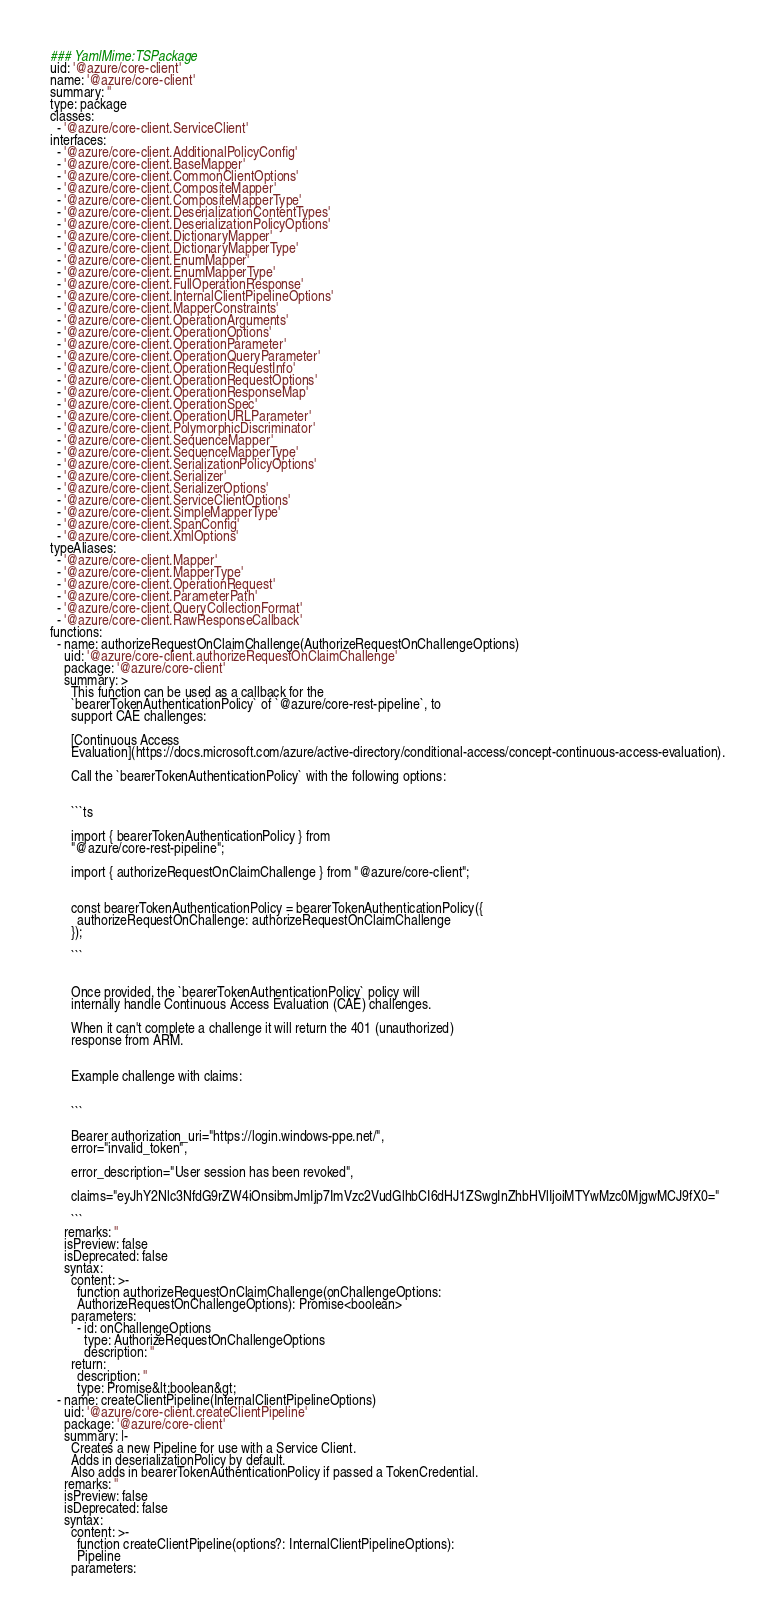Convert code to text. <code><loc_0><loc_0><loc_500><loc_500><_YAML_>### YamlMime:TSPackage
uid: '@azure/core-client'
name: '@azure/core-client'
summary: ''
type: package
classes:
  - '@azure/core-client.ServiceClient'
interfaces:
  - '@azure/core-client.AdditionalPolicyConfig'
  - '@azure/core-client.BaseMapper'
  - '@azure/core-client.CommonClientOptions'
  - '@azure/core-client.CompositeMapper'
  - '@azure/core-client.CompositeMapperType'
  - '@azure/core-client.DeserializationContentTypes'
  - '@azure/core-client.DeserializationPolicyOptions'
  - '@azure/core-client.DictionaryMapper'
  - '@azure/core-client.DictionaryMapperType'
  - '@azure/core-client.EnumMapper'
  - '@azure/core-client.EnumMapperType'
  - '@azure/core-client.FullOperationResponse'
  - '@azure/core-client.InternalClientPipelineOptions'
  - '@azure/core-client.MapperConstraints'
  - '@azure/core-client.OperationArguments'
  - '@azure/core-client.OperationOptions'
  - '@azure/core-client.OperationParameter'
  - '@azure/core-client.OperationQueryParameter'
  - '@azure/core-client.OperationRequestInfo'
  - '@azure/core-client.OperationRequestOptions'
  - '@azure/core-client.OperationResponseMap'
  - '@azure/core-client.OperationSpec'
  - '@azure/core-client.OperationURLParameter'
  - '@azure/core-client.PolymorphicDiscriminator'
  - '@azure/core-client.SequenceMapper'
  - '@azure/core-client.SequenceMapperType'
  - '@azure/core-client.SerializationPolicyOptions'
  - '@azure/core-client.Serializer'
  - '@azure/core-client.SerializerOptions'
  - '@azure/core-client.ServiceClientOptions'
  - '@azure/core-client.SimpleMapperType'
  - '@azure/core-client.SpanConfig'
  - '@azure/core-client.XmlOptions'
typeAliases:
  - '@azure/core-client.Mapper'
  - '@azure/core-client.MapperType'
  - '@azure/core-client.OperationRequest'
  - '@azure/core-client.ParameterPath'
  - '@azure/core-client.QueryCollectionFormat'
  - '@azure/core-client.RawResponseCallback'
functions:
  - name: authorizeRequestOnClaimChallenge(AuthorizeRequestOnChallengeOptions)
    uid: '@azure/core-client.authorizeRequestOnClaimChallenge'
    package: '@azure/core-client'
    summary: >
      This function can be used as a callback for the
      `bearerTokenAuthenticationPolicy` of `@azure/core-rest-pipeline`, to
      support CAE challenges:

      [Continuous Access
      Evaluation](https://docs.microsoft.com/azure/active-directory/conditional-access/concept-continuous-access-evaluation).

      Call the `bearerTokenAuthenticationPolicy` with the following options:


      ```ts

      import { bearerTokenAuthenticationPolicy } from
      "@azure/core-rest-pipeline";

      import { authorizeRequestOnClaimChallenge } from "@azure/core-client";


      const bearerTokenAuthenticationPolicy = bearerTokenAuthenticationPolicy({
        authorizeRequestOnChallenge: authorizeRequestOnClaimChallenge
      });

      ```


      Once provided, the `bearerTokenAuthenticationPolicy` policy will
      internally handle Continuous Access Evaluation (CAE) challenges.

      When it can't complete a challenge it will return the 401 (unauthorized)
      response from ARM.


      Example challenge with claims:


      ```

      Bearer authorization_uri="https://login.windows-ppe.net/",
      error="invalid_token",

      error_description="User session has been revoked",

      claims="eyJhY2Nlc3NfdG9rZW4iOnsibmJmIjp7ImVzc2VudGlhbCI6dHJ1ZSwgInZhbHVlIjoiMTYwMzc0MjgwMCJ9fX0="

      ```
    remarks: ''
    isPreview: false
    isDeprecated: false
    syntax:
      content: >-
        function authorizeRequestOnClaimChallenge(onChallengeOptions:
        AuthorizeRequestOnChallengeOptions): Promise<boolean>
      parameters:
        - id: onChallengeOptions
          type: AuthorizeRequestOnChallengeOptions
          description: ''
      return:
        description: ''
        type: Promise&lt;boolean&gt;
  - name: createClientPipeline(InternalClientPipelineOptions)
    uid: '@azure/core-client.createClientPipeline'
    package: '@azure/core-client'
    summary: |-
      Creates a new Pipeline for use with a Service Client.
      Adds in deserializationPolicy by default.
      Also adds in bearerTokenAuthenticationPolicy if passed a TokenCredential.
    remarks: ''
    isPreview: false
    isDeprecated: false
    syntax:
      content: >-
        function createClientPipeline(options?: InternalClientPipelineOptions):
        Pipeline
      parameters:</code> 